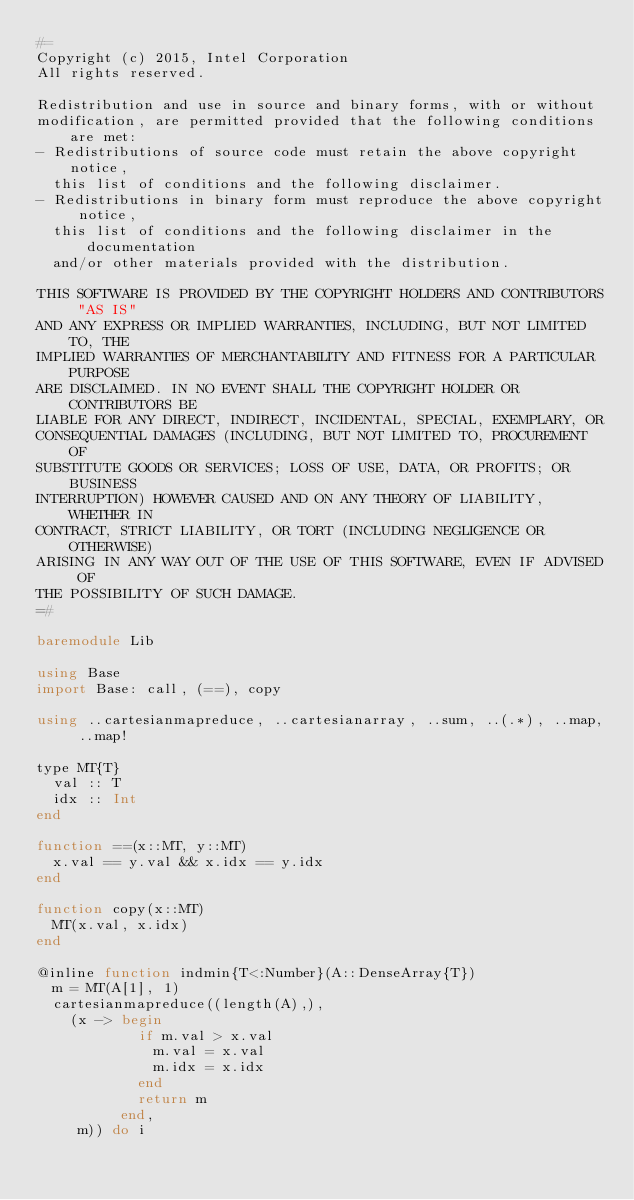<code> <loc_0><loc_0><loc_500><loc_500><_Julia_>#=
Copyright (c) 2015, Intel Corporation
All rights reserved.

Redistribution and use in source and binary forms, with or without 
modification, are permitted provided that the following conditions are met:
- Redistributions of source code must retain the above copyright notice, 
  this list of conditions and the following disclaimer.
- Redistributions in binary form must reproduce the above copyright notice, 
  this list of conditions and the following disclaimer in the documentation 
  and/or other materials provided with the distribution.

THIS SOFTWARE IS PROVIDED BY THE COPYRIGHT HOLDERS AND CONTRIBUTORS "AS IS"
AND ANY EXPRESS OR IMPLIED WARRANTIES, INCLUDING, BUT NOT LIMITED TO, THE
IMPLIED WARRANTIES OF MERCHANTABILITY AND FITNESS FOR A PARTICULAR PURPOSE
ARE DISCLAIMED. IN NO EVENT SHALL THE COPYRIGHT HOLDER OR CONTRIBUTORS BE 
LIABLE FOR ANY DIRECT, INDIRECT, INCIDENTAL, SPECIAL, EXEMPLARY, OR 
CONSEQUENTIAL DAMAGES (INCLUDING, BUT NOT LIMITED TO, PROCUREMENT OF 
SUBSTITUTE GOODS OR SERVICES; LOSS OF USE, DATA, OR PROFITS; OR BUSINESS 
INTERRUPTION) HOWEVER CAUSED AND ON ANY THEORY OF LIABILITY, WHETHER IN
CONTRACT, STRICT LIABILITY, OR TORT (INCLUDING NEGLIGENCE OR OTHERWISE) 
ARISING IN ANY WAY OUT OF THE USE OF THIS SOFTWARE, EVEN IF ADVISED OF 
THE POSSIBILITY OF SUCH DAMAGE.
=#

baremodule Lib

using Base
import Base: call, (==), copy

using ..cartesianmapreduce, ..cartesianarray, ..sum, ..(.*), ..map, ..map!

type MT{T}
  val :: T
  idx :: Int
end

function ==(x::MT, y::MT)
  x.val == y.val && x.idx == y.idx
end

function copy(x::MT)
  MT(x.val, x.idx)
end

@inline function indmin{T<:Number}(A::DenseArray{T})
  m = MT(A[1], 1)
  cartesianmapreduce((length(A),), 
    (x -> begin 
            if m.val > x.val 
              m.val = x.val
              m.idx = x.idx
            end
            return m
          end, 
     m)) do i</code> 